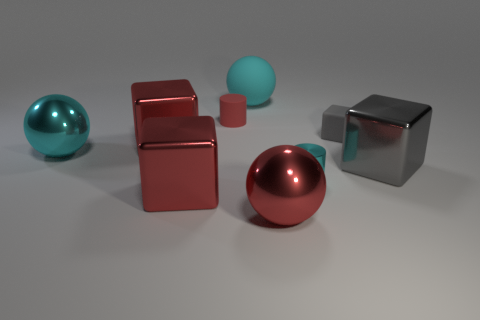How many red cubes must be subtracted to get 1 red cubes? 1 Subtract 1 cubes. How many cubes are left? 3 Add 1 blocks. How many objects exist? 10 Subtract all cylinders. How many objects are left? 7 Subtract 0 brown balls. How many objects are left? 9 Subtract all metal things. Subtract all rubber blocks. How many objects are left? 2 Add 2 big metal spheres. How many big metal spheres are left? 4 Add 5 large brown objects. How many large brown objects exist? 5 